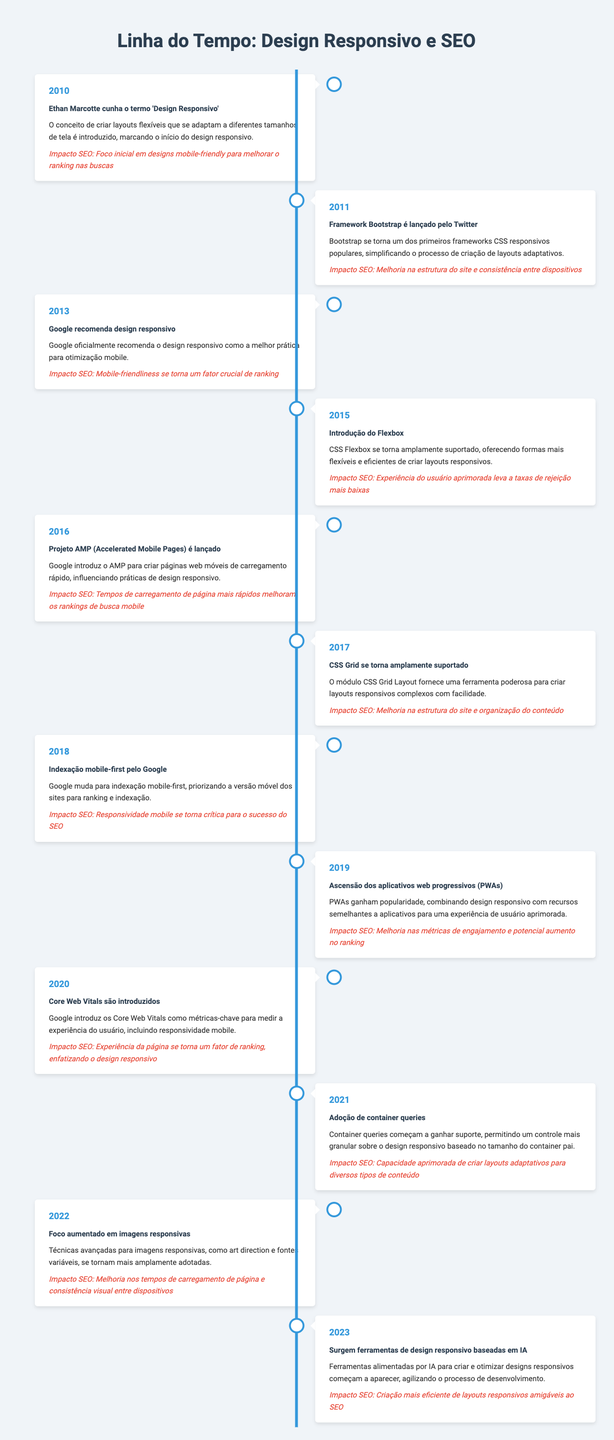What event marks the beginning of responsive web design? The table indicates that in 2010, Ethan Marcotte coined the term 'Responsive Web Design,' introducing the concept of flexible layouts that adapt to different screen sizes.
Answer: Ethan Marcotte coins the term 'Responsive Web Design' Which framework was released by Twitter in 2011? According to the table, the Bootstrap framework was launched by Twitter in 2011, becoming one of the first popular responsive CSS frameworks.
Answer: Bootstrap framework is released by Twitter What impact did the introduction of Flexbox in 2015 have on SEO? In 2015, the table states that the introduction of Flexbox enhanced user experience, which leads to lower bounce rates, positively influencing SEO.
Answer: Enhanced user experience leads to lower bounce rates True or False: Google started recommending responsive design in 2012. The table shows that Google officially recommended responsive web design in 2013, not 2012, making the statement false.
Answer: False What were the Core Web Vitals introduced in 2020 designed to measure? The table notes that Core Web Vitals were introduced to measure user experience metrics, including mobile responsiveness, emphasizing the importance of responsive design.
Answer: User experience, including mobile responsiveness In which year did mobile-first indexing by Google begin? According to the table, Google started mobile-first indexing in 2018, which was a significant shift in how websites were ranked and indexed.
Answer: 2018 How did the rise of Progressive Web Apps (PWAs) in 2019 affect engagement metrics? The table indicates that PWAs combined responsive design with app-like features, leading to improved engagement metrics and a potential boost in rankings in 2019.
Answer: Improved engagement metrics and potential ranking boost What was the primary focus of responsive images in 2022? The table reflects a focus on advanced techniques for responsive images in 2022, such as art direction and variable fonts, which improved page load times and visual consistency across devices.
Answer: Advanced techniques for responsive images What is the average year of events that emphasize mobile optimization from 2010 to 2023? The years with events focused on mobile optimization are 2010, 2013, 2018, and 2020. Summing these years gives 2010 + 2013 + 2018 + 2020 = 8059. Dividing by the number of events (4) gives an average of 2014.75, rounded down is 2014.
Answer: 2014 